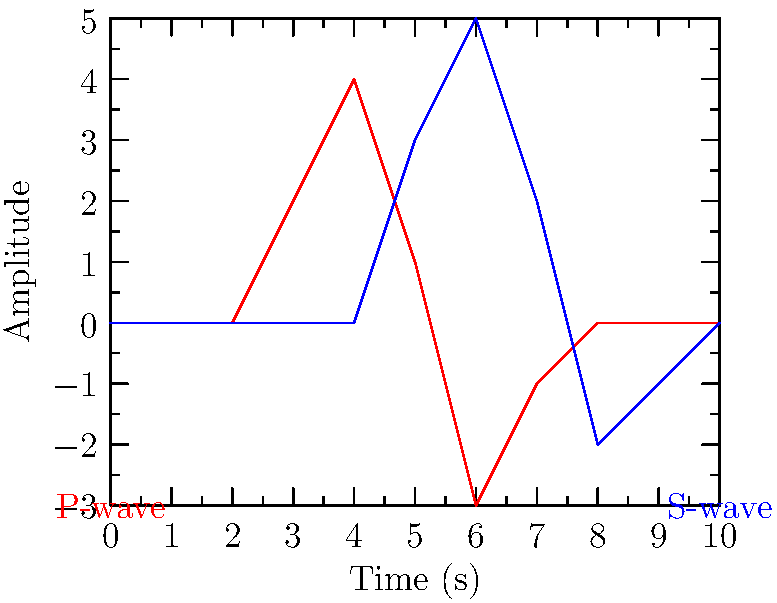Based on the seismogram shown, what is the approximate time difference between the arrival of P-waves and S-waves? To determine the time difference between P-waves and S-waves:

1. Identify the P-wave arrival:
   The red line represents the P-wave, which starts to show significant amplitude at approximately 3 seconds.

2. Identify the S-wave arrival:
   The blue line represents the S-wave, which starts to show significant amplitude at approximately 5 seconds.

3. Calculate the time difference:
   $\text{Time difference} = S\text{-wave arrival time} - P\text{-wave arrival time}$
   $\text{Time difference} = 5 \text{ seconds} - 3 \text{ seconds} = 2 \text{ seconds}$

Therefore, the approximate time difference between the arrival of P-waves and S-waves is 2 seconds.
Answer: 2 seconds 